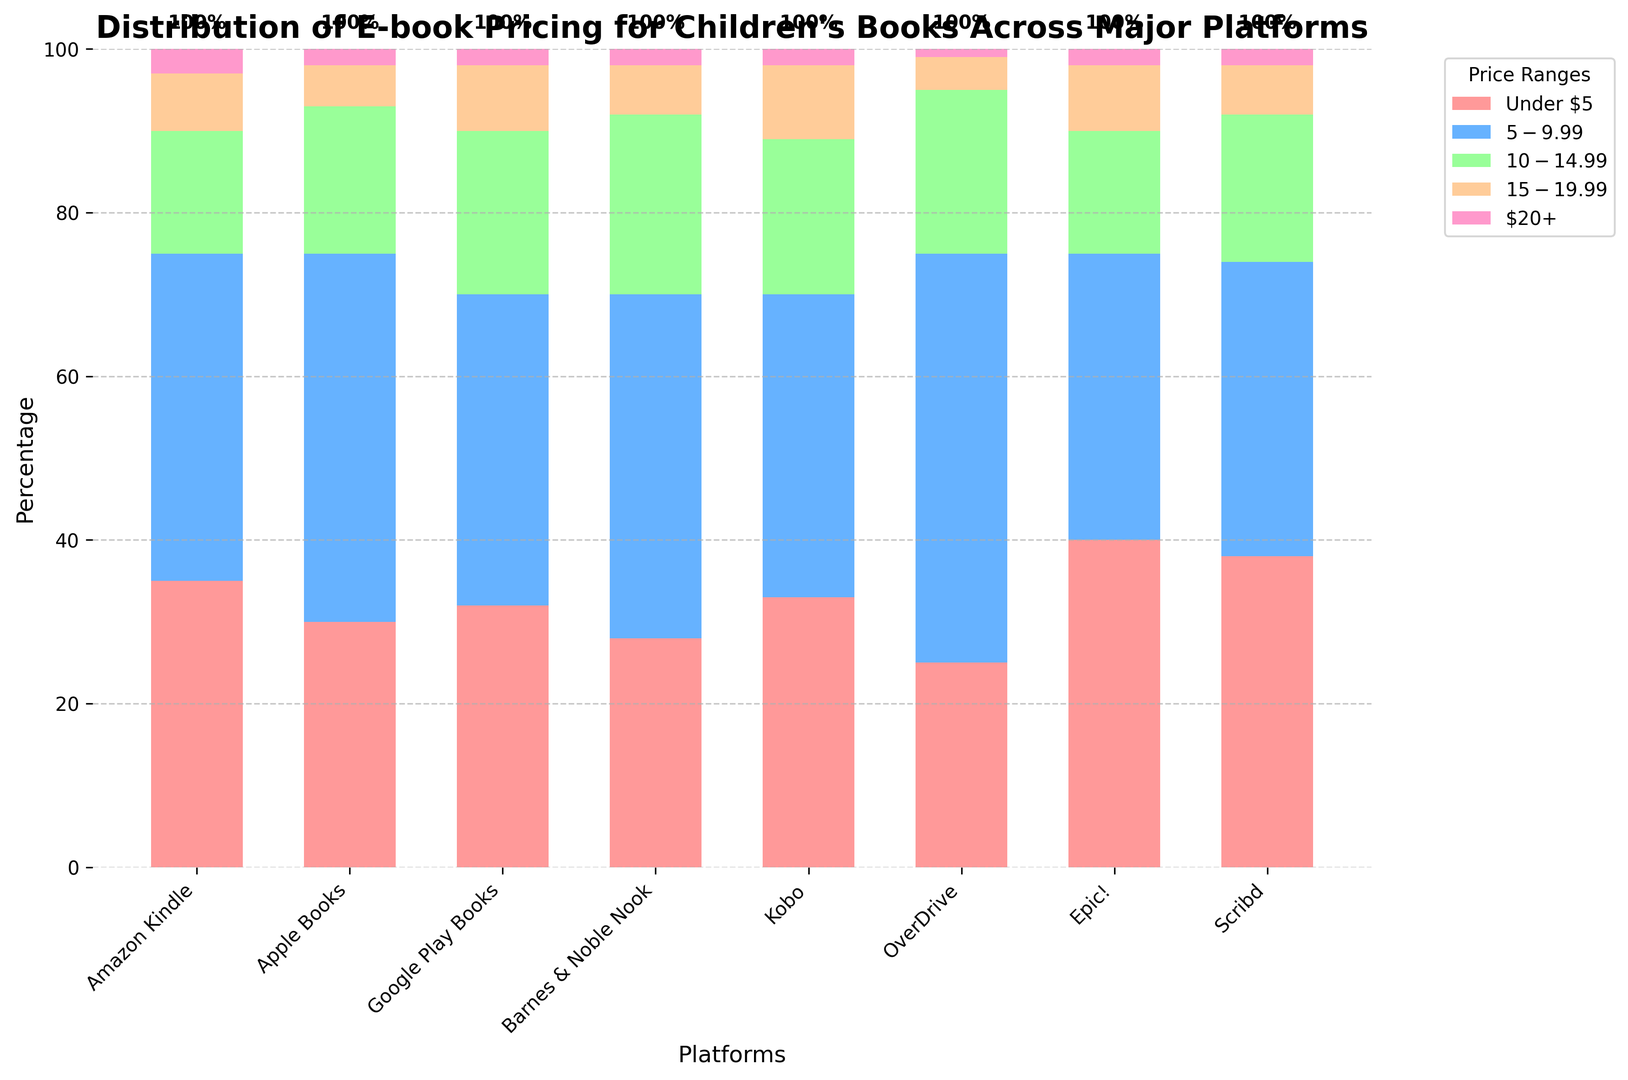What's the platform with the highest percentage of e-books priced under $5? Look at the bar labeled 'Under $5' and identify the highest bar. The tallest bar is for Epic!
Answer: Epic! Which platform has the lowest proportion of e-books priced at $20 or more? Look at the '20+' price range and identify the shortest bar. The shortest bar is for OverDrive
Answer: OverDrive Compare the percentage of e-books priced between $10-$14.99 on Apple Books and Barnes & Noble Nook. Which platform has a higher percentage? Compare the heights of the bars for the $10-$14.99 price range for both platforms. Barnes & Noble Nook's bar is taller
Answer: Barnes & Noble Nook What is the combined percentage of e-books priced under $10 on OverDrive? Add the percentages of the 'Under $5' and '$5-$9.99' price ranges for OverDrive. 25% + 50% = 75%
Answer: 75% Between Google Play Books and Kobo, which has a higher percentage of e-books in the $15-$19.99 range? Compare the heights of the bars for the $15-$19.99 price range for both platforms. Kobo has a higher percentage
Answer: Kobo Which platform has the highest overall percentage of e-books in the $5-$9.99 price range? Look for the tallest bar in the '$5-$9.99' price range across all platforms. OverDrive has the highest
Answer: OverDrive Order the platforms by the proportion of their e-books priced between $5-$9.99 from highest to lowest. By looking at the bars for the $5-$9.99 range, rank the platforms: OverDrive (50%), Apple Books (45%), Barnes & Noble Nook (42%), Amazon Kindle (40%), Google Play Books (38%), Scribd (36%), Kobo (37%), Epic! (35%).
Answer: OverDrive, Apple Books, Barnes & Noble Nook, Amazon Kindle, Google Play Books, Kobo, Scribd, Epic! What's the difference in the percentage of e-books priced under $5 between Amazon Kindle and Epic!? Subtract the percentage of Amazon Kindle under $5 from Epic!. Epic! has 40% while Amazon Kindle has 35%. 40% - 35% = 5%.
Answer: 5% Compare the percentage of e-books priced $10-$14.99 across all platforms. Which platforms have the top two highest percentages? Identify the two tallest bars in the $10-$14.99 price range. Barnes & Noble Nook (22%) and Google Play Books (20%)
Answer: Barnes & Noble Nook, Google Play Books Which platform has a higher combined percentage of e-books priced under $15, Amazon Kindle or Scribd? Sum the percentages for the 'Under $5', '$5-$9.99', and '$10-$14.99' ranges for both platforms. Amazon Kindle: 35% + 40% + 15% = 90%. Scribd: 38% + 36% + 18% = 92%. Scribd has a higher combined percentage
Answer: Scribd 